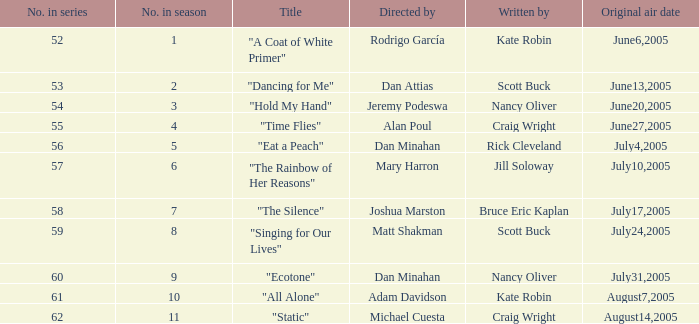When was the original air date for the season's episode 10? August7,2005. 